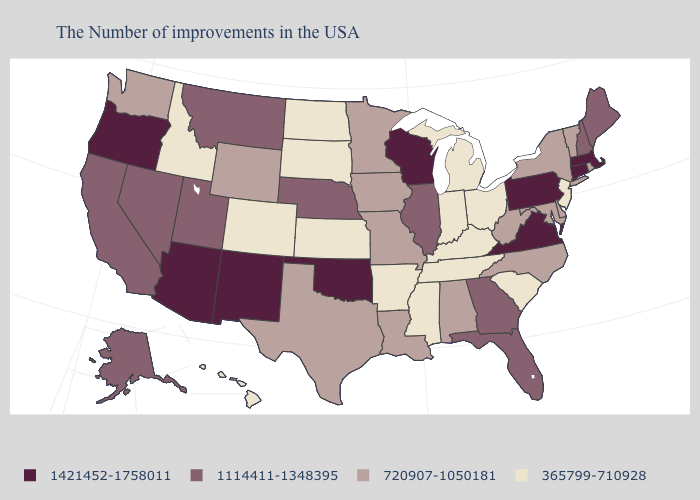What is the highest value in the South ?
Short answer required. 1421452-1758011. Name the states that have a value in the range 1421452-1758011?
Short answer required. Massachusetts, Connecticut, Pennsylvania, Virginia, Wisconsin, Oklahoma, New Mexico, Arizona, Oregon. Does the first symbol in the legend represent the smallest category?
Short answer required. No. Is the legend a continuous bar?
Answer briefly. No. What is the value of Tennessee?
Be succinct. 365799-710928. Does Nebraska have the same value as Maryland?
Write a very short answer. No. Does the first symbol in the legend represent the smallest category?
Answer briefly. No. Which states have the lowest value in the South?
Quick response, please. South Carolina, Kentucky, Tennessee, Mississippi, Arkansas. Among the states that border Michigan , which have the lowest value?
Answer briefly. Ohio, Indiana. Does Alaska have the highest value in the USA?
Short answer required. No. What is the lowest value in states that border Nebraska?
Quick response, please. 365799-710928. Name the states that have a value in the range 1114411-1348395?
Answer briefly. Maine, New Hampshire, Florida, Georgia, Illinois, Nebraska, Utah, Montana, Nevada, California, Alaska. What is the value of Nebraska?
Concise answer only. 1114411-1348395. Name the states that have a value in the range 365799-710928?
Quick response, please. New Jersey, South Carolina, Ohio, Michigan, Kentucky, Indiana, Tennessee, Mississippi, Arkansas, Kansas, South Dakota, North Dakota, Colorado, Idaho, Hawaii. What is the value of Indiana?
Answer briefly. 365799-710928. 